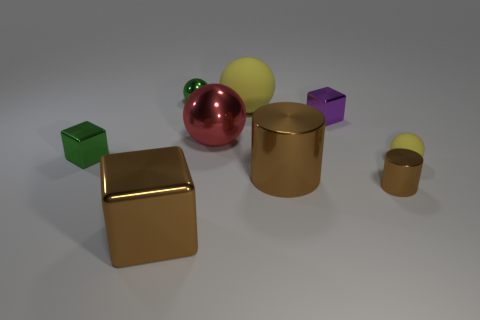There is a green thing in front of the red thing; does it have the same shape as the tiny rubber thing? The green object in front of the red one is cubic in shape, similar to the small rubber object to its right, although the sizes differ. 